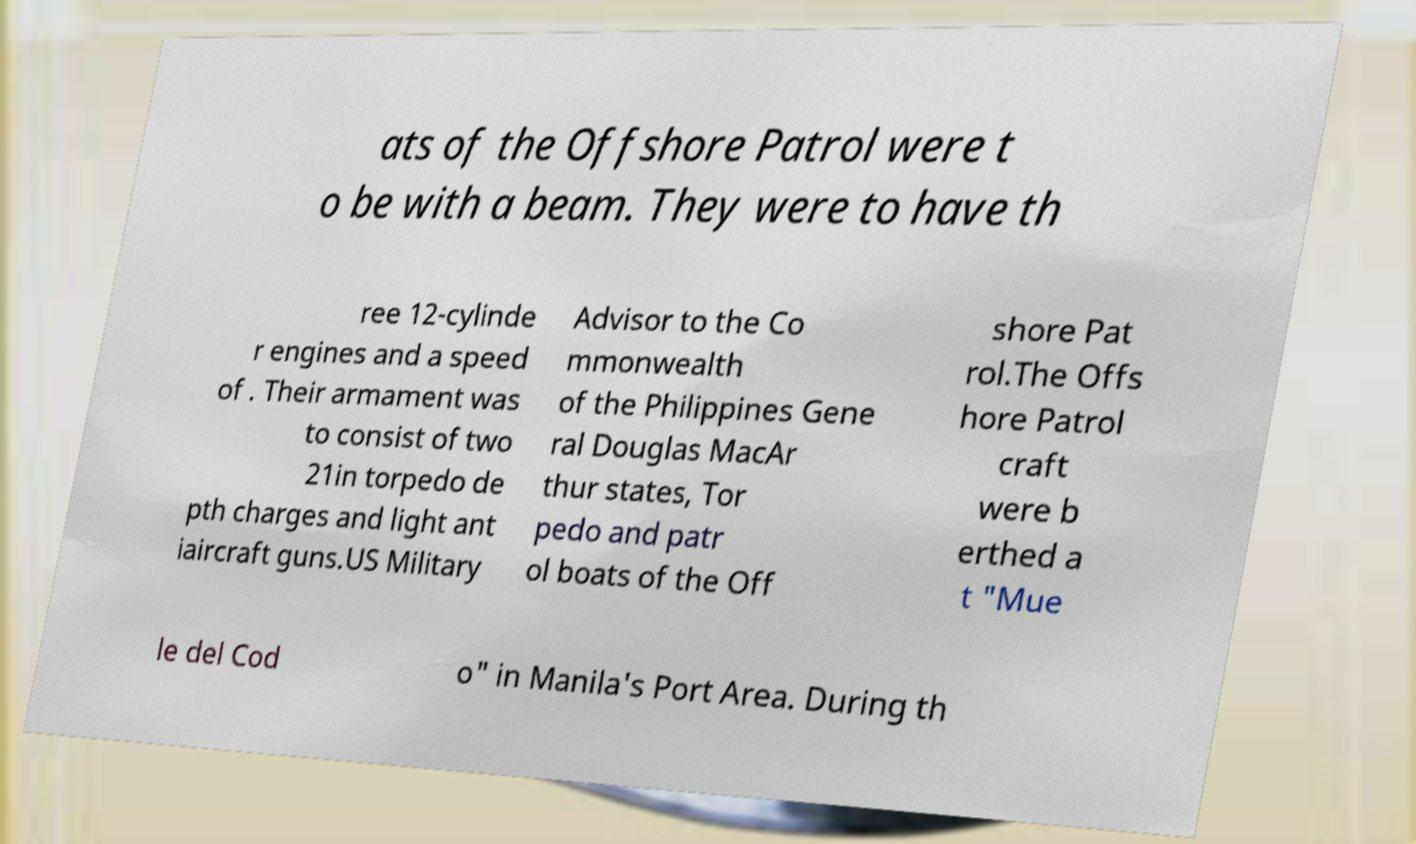There's text embedded in this image that I need extracted. Can you transcribe it verbatim? ats of the Offshore Patrol were t o be with a beam. They were to have th ree 12-cylinde r engines and a speed of . Their armament was to consist of two 21in torpedo de pth charges and light ant iaircraft guns.US Military Advisor to the Co mmonwealth of the Philippines Gene ral Douglas MacAr thur states, Tor pedo and patr ol boats of the Off shore Pat rol.The Offs hore Patrol craft were b erthed a t "Mue le del Cod o" in Manila's Port Area. During th 